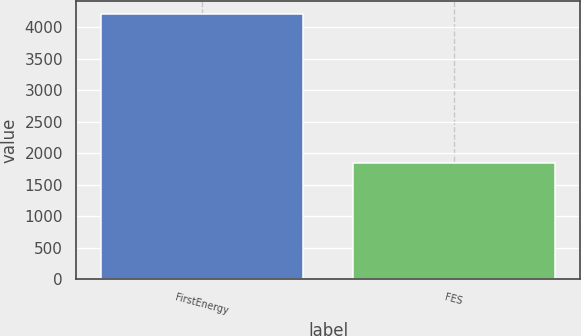Convert chart. <chart><loc_0><loc_0><loc_500><loc_500><bar_chart><fcel>FirstEnergy<fcel>FES<nl><fcel>4207<fcel>1843<nl></chart> 